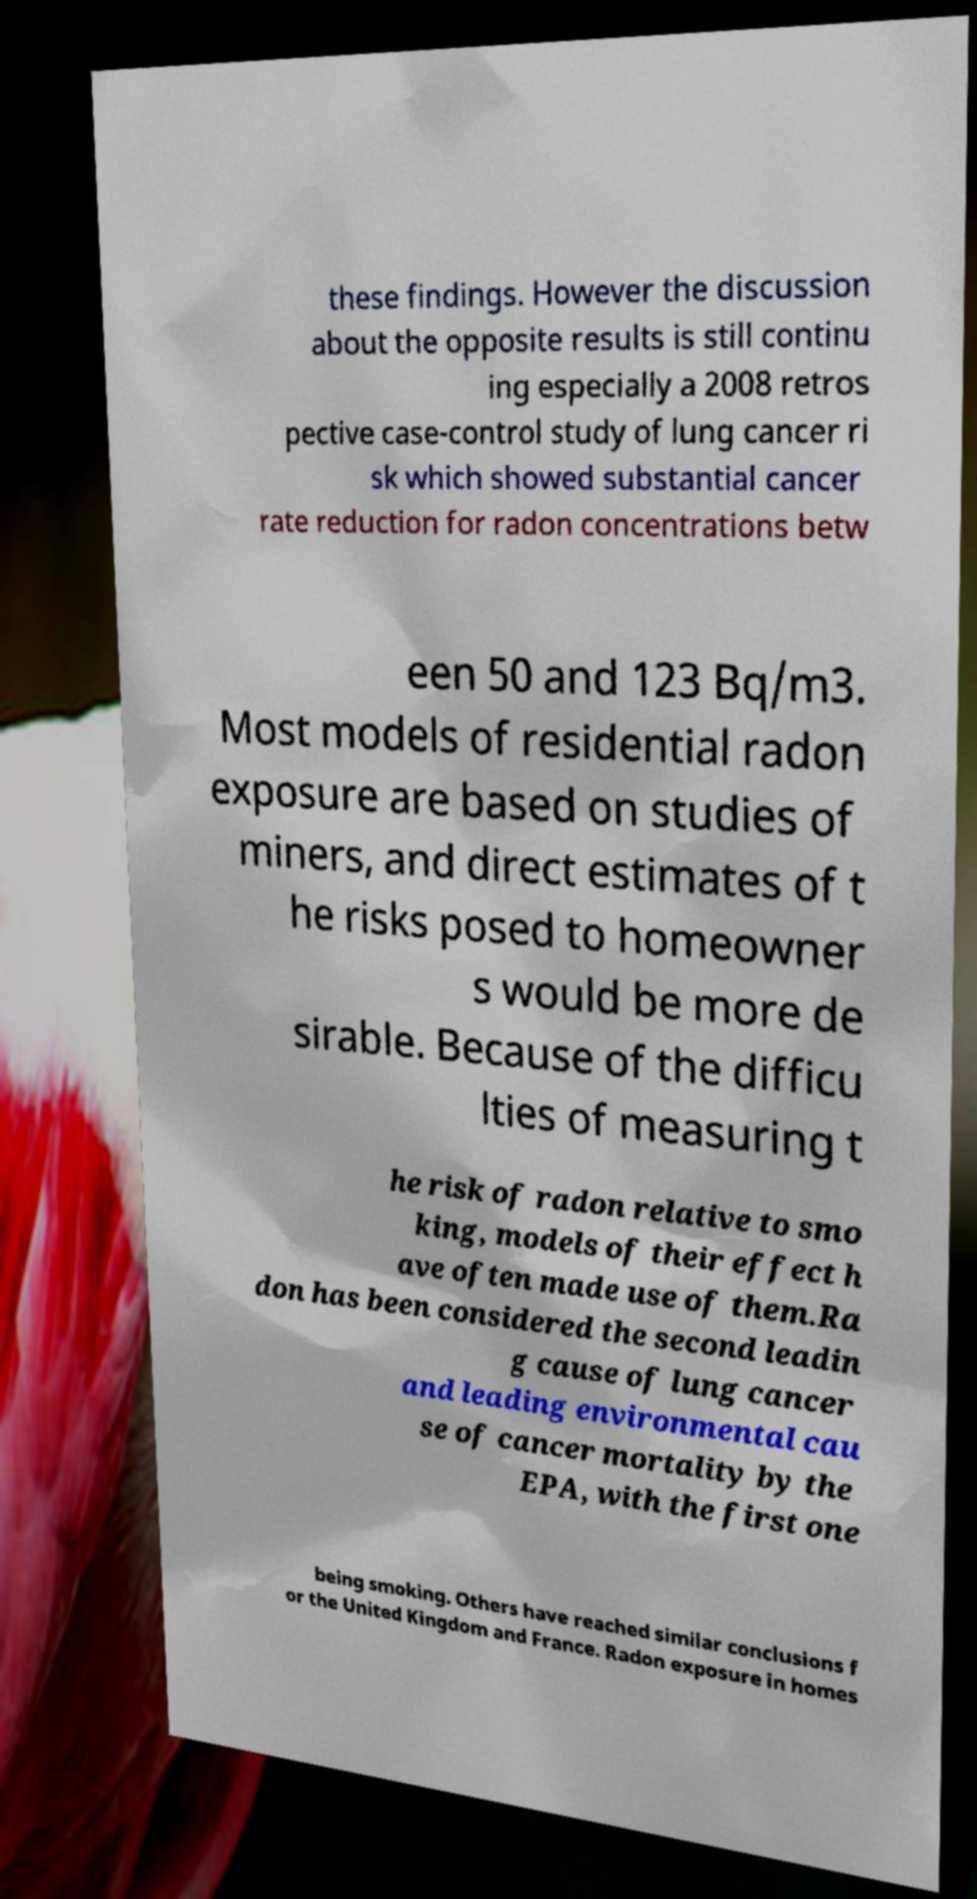There's text embedded in this image that I need extracted. Can you transcribe it verbatim? these findings. However the discussion about the opposite results is still continu ing especially a 2008 retros pective case-control study of lung cancer ri sk which showed substantial cancer rate reduction for radon concentrations betw een 50 and 123 Bq/m3. Most models of residential radon exposure are based on studies of miners, and direct estimates of t he risks posed to homeowner s would be more de sirable. Because of the difficu lties of measuring t he risk of radon relative to smo king, models of their effect h ave often made use of them.Ra don has been considered the second leadin g cause of lung cancer and leading environmental cau se of cancer mortality by the EPA, with the first one being smoking. Others have reached similar conclusions f or the United Kingdom and France. Radon exposure in homes 